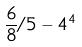Convert formula to latex. <formula><loc_0><loc_0><loc_500><loc_500>\frac { 6 } { 8 } / 5 - 4 ^ { 4 }</formula> 